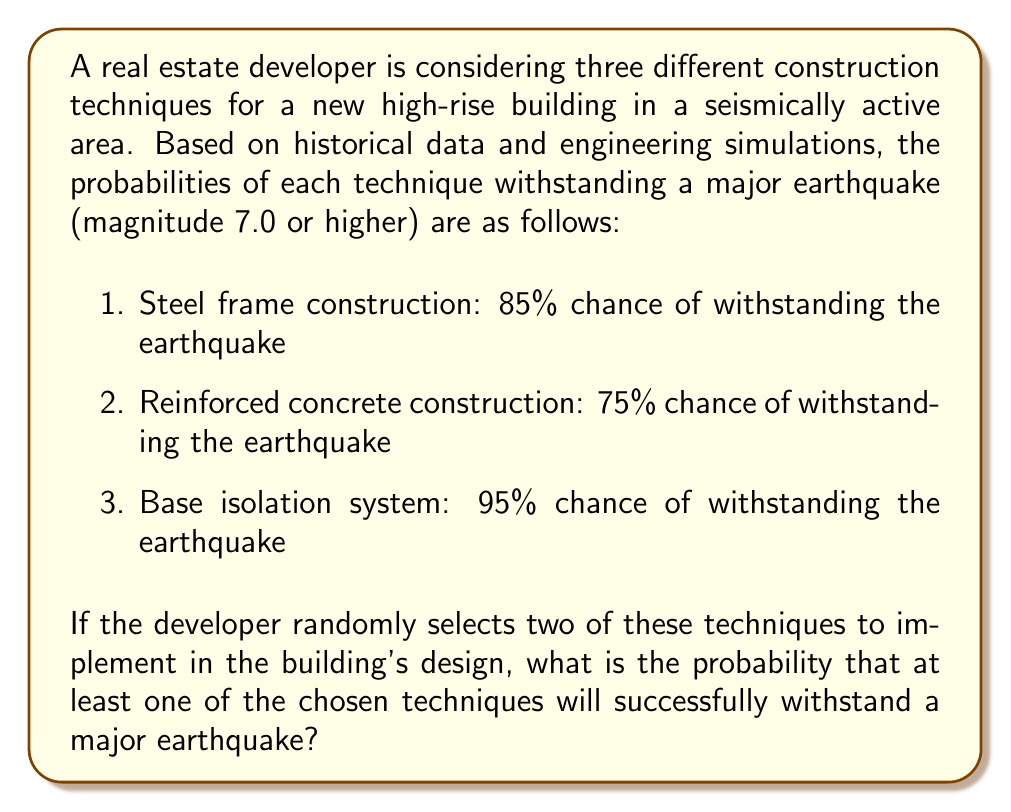Could you help me with this problem? Let's approach this step-by-step:

1) First, we need to calculate the probability of selecting any two techniques out of the three. There are $\binom{3}{2} = 3$ possible combinations.

2) Now, let's calculate the probability of failure for each technique:
   Steel frame: $1 - 0.85 = 0.15$
   Reinforced concrete: $1 - 0.75 = 0.25$
   Base isolation: $1 - 0.95 = 0.05$

3) The probability that at least one technique withstands the earthquake is the complement of the probability that both chosen techniques fail.

4) Let's calculate the probability of both techniques failing for each possible combination:
   
   Steel frame and Reinforced concrete: $0.15 \times 0.25 = 0.0375$
   Steel frame and Base isolation: $0.15 \times 0.05 = 0.0075$
   Reinforced concrete and Base isolation: $0.25 \times 0.05 = 0.0125$

5) The probability of selecting each combination is $\frac{1}{3}$, so the total probability of both chosen techniques failing is:

   $$P(\text{both fail}) = \frac{1}{3}(0.0375 + 0.0075 + 0.0125) = 0.0192$$

6) Therefore, the probability that at least one technique withstands the earthquake is:

   $$P(\text{at least one withstands}) = 1 - P(\text{both fail}) = 1 - 0.0192 = 0.9808$$

Thus, there is a 98.08% chance that at least one of the chosen techniques will successfully withstand a major earthquake.
Answer: 0.9808 or 98.08% 